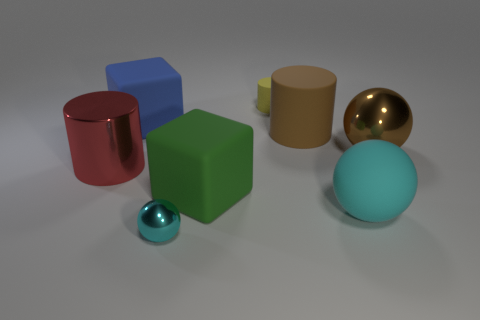There is a cube that is the same size as the green rubber object; what is its color?
Your answer should be very brief. Blue. What number of metal things are big blue things or green blocks?
Provide a succinct answer. 0. What is the color of the tiny sphere that is the same material as the large brown ball?
Provide a succinct answer. Cyan. There is a large cylinder that is to the left of the tiny thing behind the metal cylinder; what is it made of?
Make the answer very short. Metal. What number of objects are either large rubber cubes behind the big metallic ball or objects that are in front of the large blue thing?
Give a very brief answer. 7. There is a ball behind the thing left of the big rubber cube that is on the left side of the tiny metal object; what is its size?
Your answer should be very brief. Large. Are there the same number of green matte things to the left of the red shiny cylinder and tiny cyan spheres?
Offer a very short reply. No. Is there any other thing that is the same shape as the blue matte thing?
Offer a very short reply. Yes. Is the shape of the yellow thing the same as the object that is left of the big blue matte block?
Make the answer very short. Yes. What is the size of the blue object that is the same shape as the big green rubber thing?
Offer a very short reply. Large. 